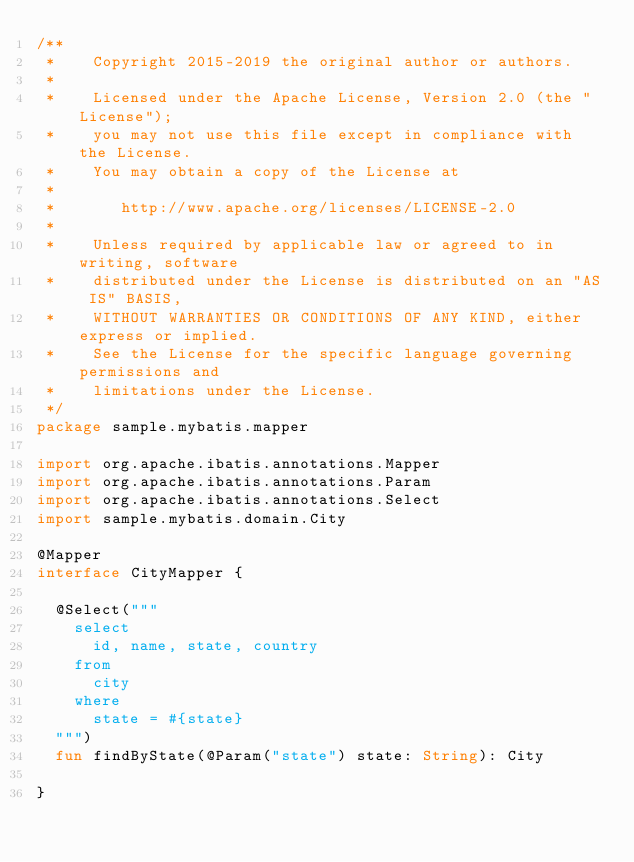<code> <loc_0><loc_0><loc_500><loc_500><_Kotlin_>/**
 *    Copyright 2015-2019 the original author or authors.
 *
 *    Licensed under the Apache License, Version 2.0 (the "License");
 *    you may not use this file except in compliance with the License.
 *    You may obtain a copy of the License at
 *
 *       http://www.apache.org/licenses/LICENSE-2.0
 *
 *    Unless required by applicable law or agreed to in writing, software
 *    distributed under the License is distributed on an "AS IS" BASIS,
 *    WITHOUT WARRANTIES OR CONDITIONS OF ANY KIND, either express or implied.
 *    See the License for the specific language governing permissions and
 *    limitations under the License.
 */
package sample.mybatis.mapper

import org.apache.ibatis.annotations.Mapper
import org.apache.ibatis.annotations.Param
import org.apache.ibatis.annotations.Select
import sample.mybatis.domain.City

@Mapper
interface CityMapper {

  @Select("""
    select
      id, name, state, country
    from
      city
    where
      state = #{state}
  """)
  fun findByState(@Param("state") state: String): City

}</code> 